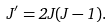<formula> <loc_0><loc_0><loc_500><loc_500>J ^ { \prime } = 2 J ( J - 1 ) .</formula> 